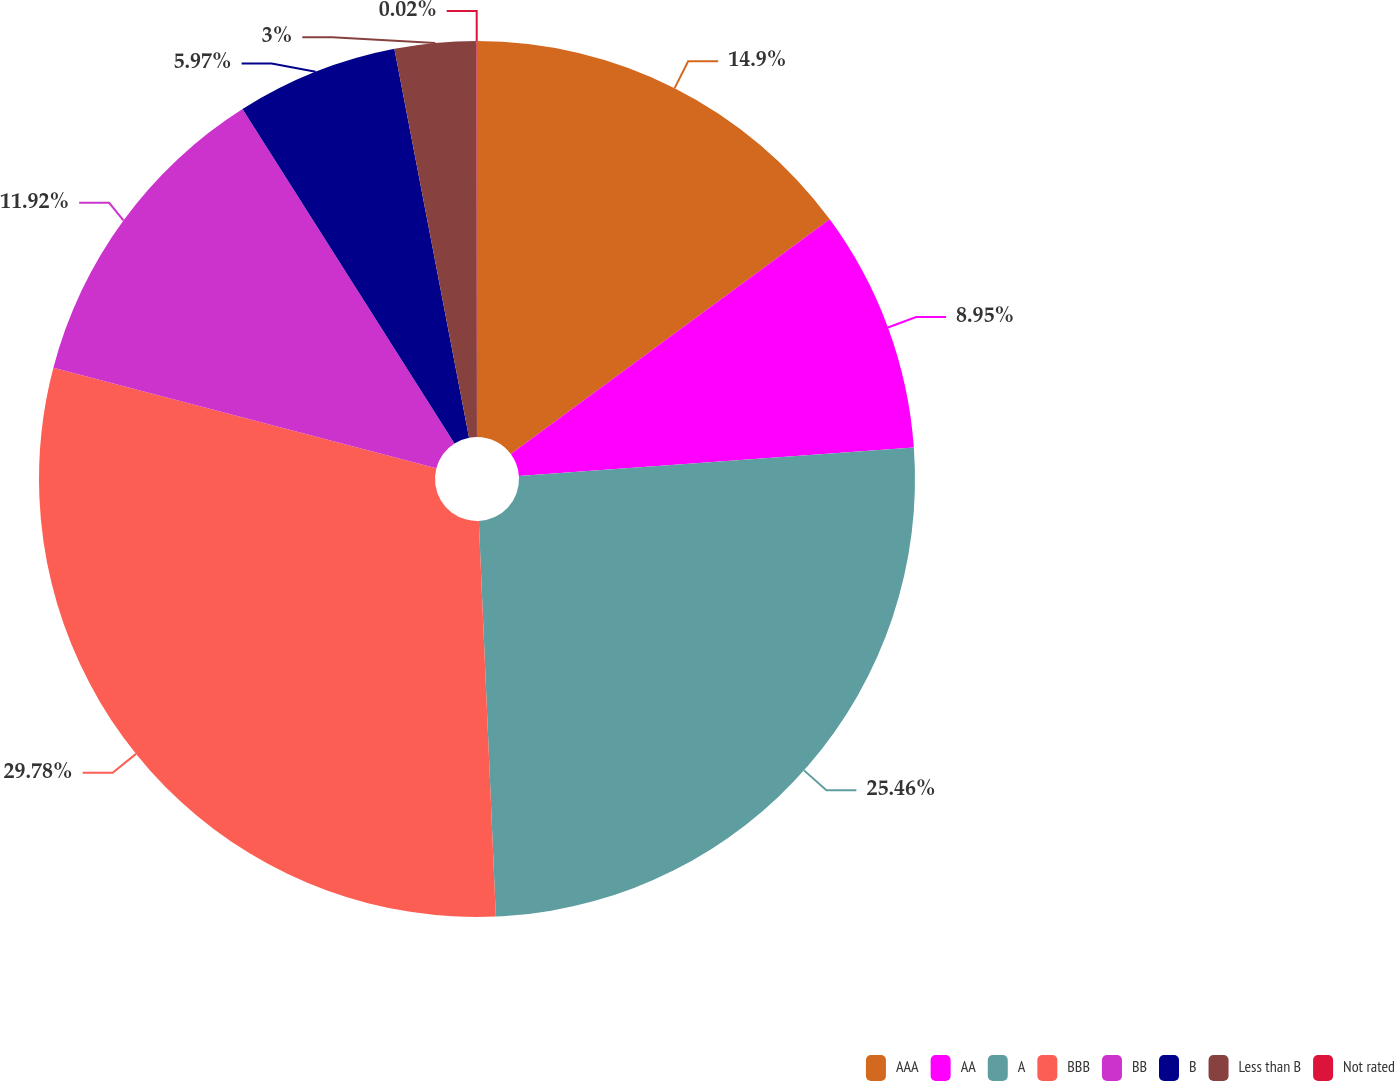Convert chart to OTSL. <chart><loc_0><loc_0><loc_500><loc_500><pie_chart><fcel>AAA<fcel>AA<fcel>A<fcel>BBB<fcel>BB<fcel>B<fcel>Less than B<fcel>Not rated<nl><fcel>14.9%<fcel>8.95%<fcel>25.46%<fcel>29.77%<fcel>11.92%<fcel>5.97%<fcel>3.0%<fcel>0.02%<nl></chart> 